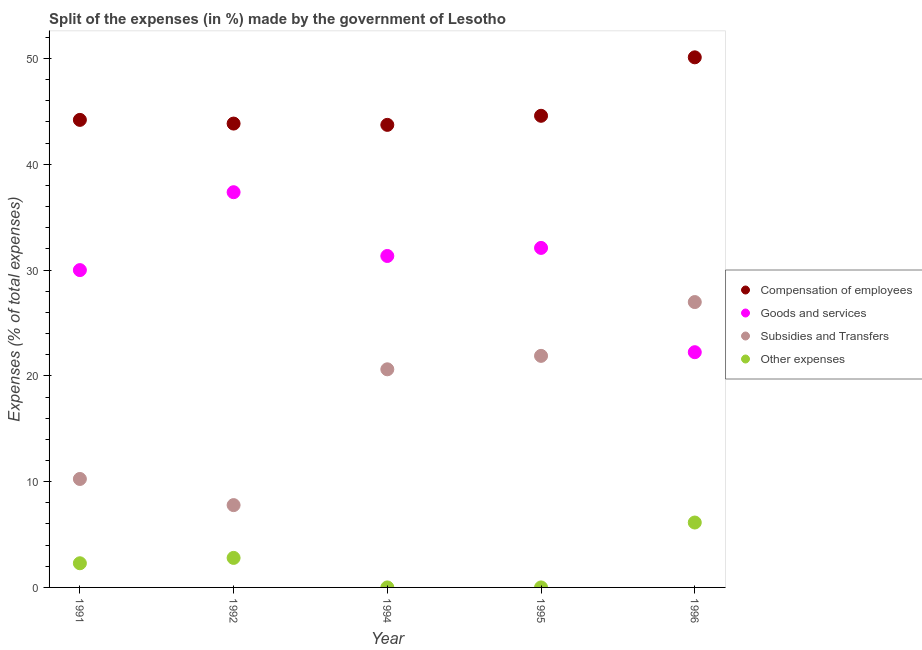Is the number of dotlines equal to the number of legend labels?
Provide a succinct answer. Yes. What is the percentage of amount spent on subsidies in 1991?
Your answer should be compact. 10.25. Across all years, what is the maximum percentage of amount spent on subsidies?
Your response must be concise. 26.98. Across all years, what is the minimum percentage of amount spent on other expenses?
Keep it short and to the point. 2.999997087200831e-5. In which year was the percentage of amount spent on other expenses maximum?
Make the answer very short. 1996. What is the total percentage of amount spent on goods and services in the graph?
Your answer should be very brief. 153.02. What is the difference between the percentage of amount spent on goods and services in 1991 and that in 1994?
Your response must be concise. -1.33. What is the difference between the percentage of amount spent on compensation of employees in 1994 and the percentage of amount spent on goods and services in 1996?
Offer a terse response. 21.49. What is the average percentage of amount spent on goods and services per year?
Your answer should be very brief. 30.6. In the year 1995, what is the difference between the percentage of amount spent on subsidies and percentage of amount spent on other expenses?
Offer a very short reply. 21.89. What is the ratio of the percentage of amount spent on compensation of employees in 1991 to that in 1995?
Your answer should be compact. 0.99. Is the percentage of amount spent on subsidies in 1992 less than that in 1995?
Your answer should be very brief. Yes. What is the difference between the highest and the second highest percentage of amount spent on subsidies?
Give a very brief answer. 5.09. What is the difference between the highest and the lowest percentage of amount spent on subsidies?
Your response must be concise. 19.2. In how many years, is the percentage of amount spent on goods and services greater than the average percentage of amount spent on goods and services taken over all years?
Make the answer very short. 3. Is it the case that in every year, the sum of the percentage of amount spent on compensation of employees and percentage of amount spent on other expenses is greater than the sum of percentage of amount spent on goods and services and percentage of amount spent on subsidies?
Provide a succinct answer. Yes. Is the percentage of amount spent on subsidies strictly less than the percentage of amount spent on other expenses over the years?
Provide a succinct answer. No. How many years are there in the graph?
Offer a very short reply. 5. What is the difference between two consecutive major ticks on the Y-axis?
Provide a short and direct response. 10. Where does the legend appear in the graph?
Your answer should be very brief. Center right. How many legend labels are there?
Your answer should be very brief. 4. How are the legend labels stacked?
Ensure brevity in your answer.  Vertical. What is the title of the graph?
Keep it short and to the point. Split of the expenses (in %) made by the government of Lesotho. Does "Secondary vocational education" appear as one of the legend labels in the graph?
Your response must be concise. No. What is the label or title of the Y-axis?
Offer a very short reply. Expenses (% of total expenses). What is the Expenses (% of total expenses) of Compensation of employees in 1991?
Keep it short and to the point. 44.2. What is the Expenses (% of total expenses) in Goods and services in 1991?
Your answer should be compact. 30. What is the Expenses (% of total expenses) in Subsidies and Transfers in 1991?
Provide a succinct answer. 10.25. What is the Expenses (% of total expenses) of Other expenses in 1991?
Your response must be concise. 2.28. What is the Expenses (% of total expenses) of Compensation of employees in 1992?
Ensure brevity in your answer.  43.85. What is the Expenses (% of total expenses) of Goods and services in 1992?
Your answer should be very brief. 37.36. What is the Expenses (% of total expenses) in Subsidies and Transfers in 1992?
Provide a short and direct response. 7.78. What is the Expenses (% of total expenses) of Other expenses in 1992?
Give a very brief answer. 2.79. What is the Expenses (% of total expenses) in Compensation of employees in 1994?
Your answer should be compact. 43.73. What is the Expenses (% of total expenses) in Goods and services in 1994?
Make the answer very short. 31.33. What is the Expenses (% of total expenses) in Subsidies and Transfers in 1994?
Offer a terse response. 20.62. What is the Expenses (% of total expenses) in Other expenses in 1994?
Your response must be concise. 2.999997087200831e-5. What is the Expenses (% of total expenses) in Compensation of employees in 1995?
Offer a terse response. 44.58. What is the Expenses (% of total expenses) in Goods and services in 1995?
Give a very brief answer. 32.1. What is the Expenses (% of total expenses) in Subsidies and Transfers in 1995?
Provide a succinct answer. 21.89. What is the Expenses (% of total expenses) of Other expenses in 1995?
Your answer should be compact. 0. What is the Expenses (% of total expenses) in Compensation of employees in 1996?
Your response must be concise. 50.11. What is the Expenses (% of total expenses) of Goods and services in 1996?
Your answer should be very brief. 22.24. What is the Expenses (% of total expenses) in Subsidies and Transfers in 1996?
Give a very brief answer. 26.98. What is the Expenses (% of total expenses) of Other expenses in 1996?
Offer a very short reply. 6.14. Across all years, what is the maximum Expenses (% of total expenses) of Compensation of employees?
Keep it short and to the point. 50.11. Across all years, what is the maximum Expenses (% of total expenses) of Goods and services?
Make the answer very short. 37.36. Across all years, what is the maximum Expenses (% of total expenses) in Subsidies and Transfers?
Provide a succinct answer. 26.98. Across all years, what is the maximum Expenses (% of total expenses) in Other expenses?
Give a very brief answer. 6.14. Across all years, what is the minimum Expenses (% of total expenses) of Compensation of employees?
Make the answer very short. 43.73. Across all years, what is the minimum Expenses (% of total expenses) of Goods and services?
Your answer should be very brief. 22.24. Across all years, what is the minimum Expenses (% of total expenses) of Subsidies and Transfers?
Ensure brevity in your answer.  7.78. Across all years, what is the minimum Expenses (% of total expenses) of Other expenses?
Your response must be concise. 2.999997087200831e-5. What is the total Expenses (% of total expenses) in Compensation of employees in the graph?
Provide a short and direct response. 226.47. What is the total Expenses (% of total expenses) in Goods and services in the graph?
Provide a succinct answer. 153.02. What is the total Expenses (% of total expenses) in Subsidies and Transfers in the graph?
Provide a succinct answer. 87.52. What is the total Expenses (% of total expenses) of Other expenses in the graph?
Make the answer very short. 11.21. What is the difference between the Expenses (% of total expenses) in Compensation of employees in 1991 and that in 1992?
Offer a terse response. 0.35. What is the difference between the Expenses (% of total expenses) in Goods and services in 1991 and that in 1992?
Make the answer very short. -7.36. What is the difference between the Expenses (% of total expenses) of Subsidies and Transfers in 1991 and that in 1992?
Offer a terse response. 2.47. What is the difference between the Expenses (% of total expenses) of Other expenses in 1991 and that in 1992?
Provide a succinct answer. -0.51. What is the difference between the Expenses (% of total expenses) of Compensation of employees in 1991 and that in 1994?
Give a very brief answer. 0.47. What is the difference between the Expenses (% of total expenses) in Goods and services in 1991 and that in 1994?
Offer a very short reply. -1.33. What is the difference between the Expenses (% of total expenses) in Subsidies and Transfers in 1991 and that in 1994?
Provide a succinct answer. -10.37. What is the difference between the Expenses (% of total expenses) in Other expenses in 1991 and that in 1994?
Ensure brevity in your answer.  2.28. What is the difference between the Expenses (% of total expenses) of Compensation of employees in 1991 and that in 1995?
Make the answer very short. -0.39. What is the difference between the Expenses (% of total expenses) of Goods and services in 1991 and that in 1995?
Ensure brevity in your answer.  -2.1. What is the difference between the Expenses (% of total expenses) of Subsidies and Transfers in 1991 and that in 1995?
Your response must be concise. -11.64. What is the difference between the Expenses (% of total expenses) of Other expenses in 1991 and that in 1995?
Offer a very short reply. 2.28. What is the difference between the Expenses (% of total expenses) of Compensation of employees in 1991 and that in 1996?
Your answer should be very brief. -5.91. What is the difference between the Expenses (% of total expenses) in Goods and services in 1991 and that in 1996?
Give a very brief answer. 7.76. What is the difference between the Expenses (% of total expenses) of Subsidies and Transfers in 1991 and that in 1996?
Provide a short and direct response. -16.72. What is the difference between the Expenses (% of total expenses) of Other expenses in 1991 and that in 1996?
Offer a very short reply. -3.85. What is the difference between the Expenses (% of total expenses) of Compensation of employees in 1992 and that in 1994?
Offer a very short reply. 0.12. What is the difference between the Expenses (% of total expenses) of Goods and services in 1992 and that in 1994?
Ensure brevity in your answer.  6.03. What is the difference between the Expenses (% of total expenses) of Subsidies and Transfers in 1992 and that in 1994?
Your answer should be very brief. -12.84. What is the difference between the Expenses (% of total expenses) in Other expenses in 1992 and that in 1994?
Offer a terse response. 2.79. What is the difference between the Expenses (% of total expenses) in Compensation of employees in 1992 and that in 1995?
Make the answer very short. -0.74. What is the difference between the Expenses (% of total expenses) of Goods and services in 1992 and that in 1995?
Offer a very short reply. 5.27. What is the difference between the Expenses (% of total expenses) of Subsidies and Transfers in 1992 and that in 1995?
Provide a succinct answer. -14.11. What is the difference between the Expenses (% of total expenses) of Other expenses in 1992 and that in 1995?
Provide a succinct answer. 2.79. What is the difference between the Expenses (% of total expenses) in Compensation of employees in 1992 and that in 1996?
Keep it short and to the point. -6.26. What is the difference between the Expenses (% of total expenses) in Goods and services in 1992 and that in 1996?
Provide a succinct answer. 15.12. What is the difference between the Expenses (% of total expenses) in Subsidies and Transfers in 1992 and that in 1996?
Offer a terse response. -19.2. What is the difference between the Expenses (% of total expenses) in Other expenses in 1992 and that in 1996?
Provide a short and direct response. -3.34. What is the difference between the Expenses (% of total expenses) of Compensation of employees in 1994 and that in 1995?
Keep it short and to the point. -0.86. What is the difference between the Expenses (% of total expenses) in Goods and services in 1994 and that in 1995?
Offer a terse response. -0.76. What is the difference between the Expenses (% of total expenses) in Subsidies and Transfers in 1994 and that in 1995?
Make the answer very short. -1.27. What is the difference between the Expenses (% of total expenses) of Other expenses in 1994 and that in 1995?
Keep it short and to the point. -0. What is the difference between the Expenses (% of total expenses) in Compensation of employees in 1994 and that in 1996?
Your answer should be compact. -6.39. What is the difference between the Expenses (% of total expenses) in Goods and services in 1994 and that in 1996?
Your response must be concise. 9.1. What is the difference between the Expenses (% of total expenses) of Subsidies and Transfers in 1994 and that in 1996?
Your answer should be compact. -6.36. What is the difference between the Expenses (% of total expenses) of Other expenses in 1994 and that in 1996?
Provide a short and direct response. -6.14. What is the difference between the Expenses (% of total expenses) of Compensation of employees in 1995 and that in 1996?
Your answer should be very brief. -5.53. What is the difference between the Expenses (% of total expenses) of Goods and services in 1995 and that in 1996?
Your answer should be compact. 9.86. What is the difference between the Expenses (% of total expenses) in Subsidies and Transfers in 1995 and that in 1996?
Make the answer very short. -5.09. What is the difference between the Expenses (% of total expenses) in Other expenses in 1995 and that in 1996?
Make the answer very short. -6.14. What is the difference between the Expenses (% of total expenses) of Compensation of employees in 1991 and the Expenses (% of total expenses) of Goods and services in 1992?
Make the answer very short. 6.84. What is the difference between the Expenses (% of total expenses) in Compensation of employees in 1991 and the Expenses (% of total expenses) in Subsidies and Transfers in 1992?
Your answer should be very brief. 36.42. What is the difference between the Expenses (% of total expenses) of Compensation of employees in 1991 and the Expenses (% of total expenses) of Other expenses in 1992?
Offer a very short reply. 41.41. What is the difference between the Expenses (% of total expenses) in Goods and services in 1991 and the Expenses (% of total expenses) in Subsidies and Transfers in 1992?
Your response must be concise. 22.22. What is the difference between the Expenses (% of total expenses) in Goods and services in 1991 and the Expenses (% of total expenses) in Other expenses in 1992?
Your answer should be compact. 27.21. What is the difference between the Expenses (% of total expenses) in Subsidies and Transfers in 1991 and the Expenses (% of total expenses) in Other expenses in 1992?
Ensure brevity in your answer.  7.46. What is the difference between the Expenses (% of total expenses) of Compensation of employees in 1991 and the Expenses (% of total expenses) of Goods and services in 1994?
Provide a succinct answer. 12.87. What is the difference between the Expenses (% of total expenses) of Compensation of employees in 1991 and the Expenses (% of total expenses) of Subsidies and Transfers in 1994?
Keep it short and to the point. 23.58. What is the difference between the Expenses (% of total expenses) of Compensation of employees in 1991 and the Expenses (% of total expenses) of Other expenses in 1994?
Provide a succinct answer. 44.2. What is the difference between the Expenses (% of total expenses) in Goods and services in 1991 and the Expenses (% of total expenses) in Subsidies and Transfers in 1994?
Give a very brief answer. 9.38. What is the difference between the Expenses (% of total expenses) of Goods and services in 1991 and the Expenses (% of total expenses) of Other expenses in 1994?
Your answer should be compact. 30. What is the difference between the Expenses (% of total expenses) in Subsidies and Transfers in 1991 and the Expenses (% of total expenses) in Other expenses in 1994?
Keep it short and to the point. 10.25. What is the difference between the Expenses (% of total expenses) of Compensation of employees in 1991 and the Expenses (% of total expenses) of Goods and services in 1995?
Ensure brevity in your answer.  12.1. What is the difference between the Expenses (% of total expenses) in Compensation of employees in 1991 and the Expenses (% of total expenses) in Subsidies and Transfers in 1995?
Your response must be concise. 22.31. What is the difference between the Expenses (% of total expenses) of Compensation of employees in 1991 and the Expenses (% of total expenses) of Other expenses in 1995?
Your answer should be very brief. 44.2. What is the difference between the Expenses (% of total expenses) of Goods and services in 1991 and the Expenses (% of total expenses) of Subsidies and Transfers in 1995?
Offer a very short reply. 8.11. What is the difference between the Expenses (% of total expenses) in Goods and services in 1991 and the Expenses (% of total expenses) in Other expenses in 1995?
Provide a short and direct response. 30. What is the difference between the Expenses (% of total expenses) in Subsidies and Transfers in 1991 and the Expenses (% of total expenses) in Other expenses in 1995?
Ensure brevity in your answer.  10.25. What is the difference between the Expenses (% of total expenses) of Compensation of employees in 1991 and the Expenses (% of total expenses) of Goods and services in 1996?
Your answer should be very brief. 21.96. What is the difference between the Expenses (% of total expenses) in Compensation of employees in 1991 and the Expenses (% of total expenses) in Subsidies and Transfers in 1996?
Your response must be concise. 17.22. What is the difference between the Expenses (% of total expenses) of Compensation of employees in 1991 and the Expenses (% of total expenses) of Other expenses in 1996?
Provide a succinct answer. 38.06. What is the difference between the Expenses (% of total expenses) of Goods and services in 1991 and the Expenses (% of total expenses) of Subsidies and Transfers in 1996?
Keep it short and to the point. 3.02. What is the difference between the Expenses (% of total expenses) of Goods and services in 1991 and the Expenses (% of total expenses) of Other expenses in 1996?
Ensure brevity in your answer.  23.86. What is the difference between the Expenses (% of total expenses) in Subsidies and Transfers in 1991 and the Expenses (% of total expenses) in Other expenses in 1996?
Your answer should be compact. 4.12. What is the difference between the Expenses (% of total expenses) in Compensation of employees in 1992 and the Expenses (% of total expenses) in Goods and services in 1994?
Offer a terse response. 12.52. What is the difference between the Expenses (% of total expenses) of Compensation of employees in 1992 and the Expenses (% of total expenses) of Subsidies and Transfers in 1994?
Provide a succinct answer. 23.23. What is the difference between the Expenses (% of total expenses) in Compensation of employees in 1992 and the Expenses (% of total expenses) in Other expenses in 1994?
Your response must be concise. 43.85. What is the difference between the Expenses (% of total expenses) in Goods and services in 1992 and the Expenses (% of total expenses) in Subsidies and Transfers in 1994?
Ensure brevity in your answer.  16.74. What is the difference between the Expenses (% of total expenses) of Goods and services in 1992 and the Expenses (% of total expenses) of Other expenses in 1994?
Offer a very short reply. 37.36. What is the difference between the Expenses (% of total expenses) of Subsidies and Transfers in 1992 and the Expenses (% of total expenses) of Other expenses in 1994?
Offer a very short reply. 7.78. What is the difference between the Expenses (% of total expenses) of Compensation of employees in 1992 and the Expenses (% of total expenses) of Goods and services in 1995?
Make the answer very short. 11.75. What is the difference between the Expenses (% of total expenses) of Compensation of employees in 1992 and the Expenses (% of total expenses) of Subsidies and Transfers in 1995?
Offer a very short reply. 21.96. What is the difference between the Expenses (% of total expenses) in Compensation of employees in 1992 and the Expenses (% of total expenses) in Other expenses in 1995?
Your answer should be compact. 43.85. What is the difference between the Expenses (% of total expenses) in Goods and services in 1992 and the Expenses (% of total expenses) in Subsidies and Transfers in 1995?
Your response must be concise. 15.47. What is the difference between the Expenses (% of total expenses) of Goods and services in 1992 and the Expenses (% of total expenses) of Other expenses in 1995?
Provide a short and direct response. 37.36. What is the difference between the Expenses (% of total expenses) in Subsidies and Transfers in 1992 and the Expenses (% of total expenses) in Other expenses in 1995?
Offer a terse response. 7.78. What is the difference between the Expenses (% of total expenses) of Compensation of employees in 1992 and the Expenses (% of total expenses) of Goods and services in 1996?
Make the answer very short. 21.61. What is the difference between the Expenses (% of total expenses) of Compensation of employees in 1992 and the Expenses (% of total expenses) of Subsidies and Transfers in 1996?
Offer a terse response. 16.87. What is the difference between the Expenses (% of total expenses) in Compensation of employees in 1992 and the Expenses (% of total expenses) in Other expenses in 1996?
Provide a short and direct response. 37.71. What is the difference between the Expenses (% of total expenses) of Goods and services in 1992 and the Expenses (% of total expenses) of Subsidies and Transfers in 1996?
Give a very brief answer. 10.38. What is the difference between the Expenses (% of total expenses) in Goods and services in 1992 and the Expenses (% of total expenses) in Other expenses in 1996?
Give a very brief answer. 31.23. What is the difference between the Expenses (% of total expenses) in Subsidies and Transfers in 1992 and the Expenses (% of total expenses) in Other expenses in 1996?
Provide a succinct answer. 1.65. What is the difference between the Expenses (% of total expenses) in Compensation of employees in 1994 and the Expenses (% of total expenses) in Goods and services in 1995?
Make the answer very short. 11.63. What is the difference between the Expenses (% of total expenses) in Compensation of employees in 1994 and the Expenses (% of total expenses) in Subsidies and Transfers in 1995?
Your answer should be very brief. 21.84. What is the difference between the Expenses (% of total expenses) in Compensation of employees in 1994 and the Expenses (% of total expenses) in Other expenses in 1995?
Your answer should be compact. 43.73. What is the difference between the Expenses (% of total expenses) of Goods and services in 1994 and the Expenses (% of total expenses) of Subsidies and Transfers in 1995?
Your response must be concise. 9.44. What is the difference between the Expenses (% of total expenses) of Goods and services in 1994 and the Expenses (% of total expenses) of Other expenses in 1995?
Ensure brevity in your answer.  31.33. What is the difference between the Expenses (% of total expenses) in Subsidies and Transfers in 1994 and the Expenses (% of total expenses) in Other expenses in 1995?
Offer a very short reply. 20.62. What is the difference between the Expenses (% of total expenses) in Compensation of employees in 1994 and the Expenses (% of total expenses) in Goods and services in 1996?
Provide a short and direct response. 21.49. What is the difference between the Expenses (% of total expenses) in Compensation of employees in 1994 and the Expenses (% of total expenses) in Subsidies and Transfers in 1996?
Ensure brevity in your answer.  16.75. What is the difference between the Expenses (% of total expenses) of Compensation of employees in 1994 and the Expenses (% of total expenses) of Other expenses in 1996?
Your answer should be very brief. 37.59. What is the difference between the Expenses (% of total expenses) of Goods and services in 1994 and the Expenses (% of total expenses) of Subsidies and Transfers in 1996?
Keep it short and to the point. 4.36. What is the difference between the Expenses (% of total expenses) of Goods and services in 1994 and the Expenses (% of total expenses) of Other expenses in 1996?
Offer a very short reply. 25.2. What is the difference between the Expenses (% of total expenses) in Subsidies and Transfers in 1994 and the Expenses (% of total expenses) in Other expenses in 1996?
Your answer should be very brief. 14.48. What is the difference between the Expenses (% of total expenses) of Compensation of employees in 1995 and the Expenses (% of total expenses) of Goods and services in 1996?
Your answer should be very brief. 22.35. What is the difference between the Expenses (% of total expenses) of Compensation of employees in 1995 and the Expenses (% of total expenses) of Subsidies and Transfers in 1996?
Your response must be concise. 17.61. What is the difference between the Expenses (% of total expenses) of Compensation of employees in 1995 and the Expenses (% of total expenses) of Other expenses in 1996?
Keep it short and to the point. 38.45. What is the difference between the Expenses (% of total expenses) in Goods and services in 1995 and the Expenses (% of total expenses) in Subsidies and Transfers in 1996?
Your answer should be very brief. 5.12. What is the difference between the Expenses (% of total expenses) of Goods and services in 1995 and the Expenses (% of total expenses) of Other expenses in 1996?
Make the answer very short. 25.96. What is the difference between the Expenses (% of total expenses) of Subsidies and Transfers in 1995 and the Expenses (% of total expenses) of Other expenses in 1996?
Make the answer very short. 15.75. What is the average Expenses (% of total expenses) of Compensation of employees per year?
Provide a short and direct response. 45.29. What is the average Expenses (% of total expenses) in Goods and services per year?
Offer a very short reply. 30.6. What is the average Expenses (% of total expenses) of Subsidies and Transfers per year?
Ensure brevity in your answer.  17.5. What is the average Expenses (% of total expenses) in Other expenses per year?
Provide a succinct answer. 2.24. In the year 1991, what is the difference between the Expenses (% of total expenses) in Compensation of employees and Expenses (% of total expenses) in Goods and services?
Make the answer very short. 14.2. In the year 1991, what is the difference between the Expenses (% of total expenses) in Compensation of employees and Expenses (% of total expenses) in Subsidies and Transfers?
Ensure brevity in your answer.  33.95. In the year 1991, what is the difference between the Expenses (% of total expenses) in Compensation of employees and Expenses (% of total expenses) in Other expenses?
Your response must be concise. 41.91. In the year 1991, what is the difference between the Expenses (% of total expenses) of Goods and services and Expenses (% of total expenses) of Subsidies and Transfers?
Make the answer very short. 19.74. In the year 1991, what is the difference between the Expenses (% of total expenses) of Goods and services and Expenses (% of total expenses) of Other expenses?
Your answer should be compact. 27.71. In the year 1991, what is the difference between the Expenses (% of total expenses) of Subsidies and Transfers and Expenses (% of total expenses) of Other expenses?
Your response must be concise. 7.97. In the year 1992, what is the difference between the Expenses (% of total expenses) in Compensation of employees and Expenses (% of total expenses) in Goods and services?
Keep it short and to the point. 6.49. In the year 1992, what is the difference between the Expenses (% of total expenses) in Compensation of employees and Expenses (% of total expenses) in Subsidies and Transfers?
Make the answer very short. 36.07. In the year 1992, what is the difference between the Expenses (% of total expenses) in Compensation of employees and Expenses (% of total expenses) in Other expenses?
Give a very brief answer. 41.06. In the year 1992, what is the difference between the Expenses (% of total expenses) of Goods and services and Expenses (% of total expenses) of Subsidies and Transfers?
Offer a very short reply. 29.58. In the year 1992, what is the difference between the Expenses (% of total expenses) of Goods and services and Expenses (% of total expenses) of Other expenses?
Offer a terse response. 34.57. In the year 1992, what is the difference between the Expenses (% of total expenses) in Subsidies and Transfers and Expenses (% of total expenses) in Other expenses?
Ensure brevity in your answer.  4.99. In the year 1994, what is the difference between the Expenses (% of total expenses) in Compensation of employees and Expenses (% of total expenses) in Goods and services?
Ensure brevity in your answer.  12.39. In the year 1994, what is the difference between the Expenses (% of total expenses) of Compensation of employees and Expenses (% of total expenses) of Subsidies and Transfers?
Offer a very short reply. 23.11. In the year 1994, what is the difference between the Expenses (% of total expenses) in Compensation of employees and Expenses (% of total expenses) in Other expenses?
Keep it short and to the point. 43.73. In the year 1994, what is the difference between the Expenses (% of total expenses) in Goods and services and Expenses (% of total expenses) in Subsidies and Transfers?
Offer a very short reply. 10.71. In the year 1994, what is the difference between the Expenses (% of total expenses) in Goods and services and Expenses (% of total expenses) in Other expenses?
Offer a very short reply. 31.33. In the year 1994, what is the difference between the Expenses (% of total expenses) in Subsidies and Transfers and Expenses (% of total expenses) in Other expenses?
Your answer should be compact. 20.62. In the year 1995, what is the difference between the Expenses (% of total expenses) in Compensation of employees and Expenses (% of total expenses) in Goods and services?
Ensure brevity in your answer.  12.49. In the year 1995, what is the difference between the Expenses (% of total expenses) in Compensation of employees and Expenses (% of total expenses) in Subsidies and Transfers?
Ensure brevity in your answer.  22.7. In the year 1995, what is the difference between the Expenses (% of total expenses) in Compensation of employees and Expenses (% of total expenses) in Other expenses?
Keep it short and to the point. 44.58. In the year 1995, what is the difference between the Expenses (% of total expenses) of Goods and services and Expenses (% of total expenses) of Subsidies and Transfers?
Your answer should be very brief. 10.21. In the year 1995, what is the difference between the Expenses (% of total expenses) of Goods and services and Expenses (% of total expenses) of Other expenses?
Provide a succinct answer. 32.1. In the year 1995, what is the difference between the Expenses (% of total expenses) of Subsidies and Transfers and Expenses (% of total expenses) of Other expenses?
Give a very brief answer. 21.89. In the year 1996, what is the difference between the Expenses (% of total expenses) in Compensation of employees and Expenses (% of total expenses) in Goods and services?
Keep it short and to the point. 27.88. In the year 1996, what is the difference between the Expenses (% of total expenses) of Compensation of employees and Expenses (% of total expenses) of Subsidies and Transfers?
Keep it short and to the point. 23.14. In the year 1996, what is the difference between the Expenses (% of total expenses) in Compensation of employees and Expenses (% of total expenses) in Other expenses?
Provide a short and direct response. 43.98. In the year 1996, what is the difference between the Expenses (% of total expenses) of Goods and services and Expenses (% of total expenses) of Subsidies and Transfers?
Offer a terse response. -4.74. In the year 1996, what is the difference between the Expenses (% of total expenses) in Goods and services and Expenses (% of total expenses) in Other expenses?
Make the answer very short. 16.1. In the year 1996, what is the difference between the Expenses (% of total expenses) in Subsidies and Transfers and Expenses (% of total expenses) in Other expenses?
Keep it short and to the point. 20.84. What is the ratio of the Expenses (% of total expenses) in Compensation of employees in 1991 to that in 1992?
Provide a succinct answer. 1.01. What is the ratio of the Expenses (% of total expenses) in Goods and services in 1991 to that in 1992?
Your answer should be compact. 0.8. What is the ratio of the Expenses (% of total expenses) in Subsidies and Transfers in 1991 to that in 1992?
Make the answer very short. 1.32. What is the ratio of the Expenses (% of total expenses) of Other expenses in 1991 to that in 1992?
Your response must be concise. 0.82. What is the ratio of the Expenses (% of total expenses) in Compensation of employees in 1991 to that in 1994?
Make the answer very short. 1.01. What is the ratio of the Expenses (% of total expenses) of Goods and services in 1991 to that in 1994?
Provide a short and direct response. 0.96. What is the ratio of the Expenses (% of total expenses) in Subsidies and Transfers in 1991 to that in 1994?
Offer a terse response. 0.5. What is the ratio of the Expenses (% of total expenses) in Other expenses in 1991 to that in 1994?
Provide a succinct answer. 7.62e+04. What is the ratio of the Expenses (% of total expenses) of Goods and services in 1991 to that in 1995?
Provide a succinct answer. 0.93. What is the ratio of the Expenses (% of total expenses) of Subsidies and Transfers in 1991 to that in 1995?
Your response must be concise. 0.47. What is the ratio of the Expenses (% of total expenses) in Other expenses in 1991 to that in 1995?
Offer a terse response. 2.28e+04. What is the ratio of the Expenses (% of total expenses) in Compensation of employees in 1991 to that in 1996?
Keep it short and to the point. 0.88. What is the ratio of the Expenses (% of total expenses) in Goods and services in 1991 to that in 1996?
Keep it short and to the point. 1.35. What is the ratio of the Expenses (% of total expenses) in Subsidies and Transfers in 1991 to that in 1996?
Your answer should be compact. 0.38. What is the ratio of the Expenses (% of total expenses) in Other expenses in 1991 to that in 1996?
Provide a succinct answer. 0.37. What is the ratio of the Expenses (% of total expenses) in Goods and services in 1992 to that in 1994?
Provide a short and direct response. 1.19. What is the ratio of the Expenses (% of total expenses) of Subsidies and Transfers in 1992 to that in 1994?
Your response must be concise. 0.38. What is the ratio of the Expenses (% of total expenses) in Other expenses in 1992 to that in 1994?
Your response must be concise. 9.30e+04. What is the ratio of the Expenses (% of total expenses) of Compensation of employees in 1992 to that in 1995?
Ensure brevity in your answer.  0.98. What is the ratio of the Expenses (% of total expenses) in Goods and services in 1992 to that in 1995?
Your answer should be very brief. 1.16. What is the ratio of the Expenses (% of total expenses) of Subsidies and Transfers in 1992 to that in 1995?
Make the answer very short. 0.36. What is the ratio of the Expenses (% of total expenses) of Other expenses in 1992 to that in 1995?
Give a very brief answer. 2.78e+04. What is the ratio of the Expenses (% of total expenses) of Goods and services in 1992 to that in 1996?
Your answer should be compact. 1.68. What is the ratio of the Expenses (% of total expenses) of Subsidies and Transfers in 1992 to that in 1996?
Give a very brief answer. 0.29. What is the ratio of the Expenses (% of total expenses) of Other expenses in 1992 to that in 1996?
Ensure brevity in your answer.  0.45. What is the ratio of the Expenses (% of total expenses) of Compensation of employees in 1994 to that in 1995?
Give a very brief answer. 0.98. What is the ratio of the Expenses (% of total expenses) of Goods and services in 1994 to that in 1995?
Your answer should be compact. 0.98. What is the ratio of the Expenses (% of total expenses) in Subsidies and Transfers in 1994 to that in 1995?
Give a very brief answer. 0.94. What is the ratio of the Expenses (% of total expenses) in Other expenses in 1994 to that in 1995?
Provide a succinct answer. 0.3. What is the ratio of the Expenses (% of total expenses) of Compensation of employees in 1994 to that in 1996?
Make the answer very short. 0.87. What is the ratio of the Expenses (% of total expenses) in Goods and services in 1994 to that in 1996?
Keep it short and to the point. 1.41. What is the ratio of the Expenses (% of total expenses) in Subsidies and Transfers in 1994 to that in 1996?
Offer a terse response. 0.76. What is the ratio of the Expenses (% of total expenses) in Other expenses in 1994 to that in 1996?
Provide a succinct answer. 0. What is the ratio of the Expenses (% of total expenses) of Compensation of employees in 1995 to that in 1996?
Make the answer very short. 0.89. What is the ratio of the Expenses (% of total expenses) in Goods and services in 1995 to that in 1996?
Offer a very short reply. 1.44. What is the ratio of the Expenses (% of total expenses) of Subsidies and Transfers in 1995 to that in 1996?
Keep it short and to the point. 0.81. What is the difference between the highest and the second highest Expenses (% of total expenses) of Compensation of employees?
Your answer should be compact. 5.53. What is the difference between the highest and the second highest Expenses (% of total expenses) in Goods and services?
Your answer should be very brief. 5.27. What is the difference between the highest and the second highest Expenses (% of total expenses) in Subsidies and Transfers?
Your response must be concise. 5.09. What is the difference between the highest and the second highest Expenses (% of total expenses) in Other expenses?
Offer a very short reply. 3.34. What is the difference between the highest and the lowest Expenses (% of total expenses) of Compensation of employees?
Your answer should be compact. 6.39. What is the difference between the highest and the lowest Expenses (% of total expenses) in Goods and services?
Offer a very short reply. 15.12. What is the difference between the highest and the lowest Expenses (% of total expenses) in Subsidies and Transfers?
Your response must be concise. 19.2. What is the difference between the highest and the lowest Expenses (% of total expenses) of Other expenses?
Provide a short and direct response. 6.14. 